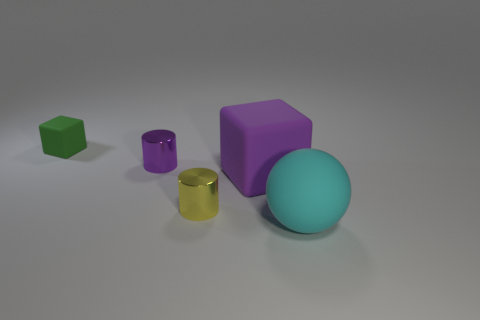How many objects are tiny things that are in front of the small matte object or green matte objects behind the tiny yellow object?
Offer a very short reply. 3. What color is the metal thing that is in front of the block on the right side of the purple metal thing?
Offer a very short reply. Yellow. What color is the large block that is made of the same material as the tiny green block?
Ensure brevity in your answer.  Purple. How many tiny metallic things have the same color as the large rubber cube?
Give a very brief answer. 1. What number of things are either small gray metal cubes or cyan matte things?
Give a very brief answer. 1. What is the shape of the yellow shiny object that is the same size as the green matte cube?
Your answer should be very brief. Cylinder. What number of tiny things are in front of the tiny green rubber block and behind the purple matte object?
Ensure brevity in your answer.  1. What is the material of the large object left of the big sphere?
Provide a succinct answer. Rubber. What is the size of the purple object that is the same material as the cyan sphere?
Provide a succinct answer. Large. There is a cube that is on the right side of the green block; is its size the same as the block behind the large purple rubber thing?
Your answer should be very brief. No. 